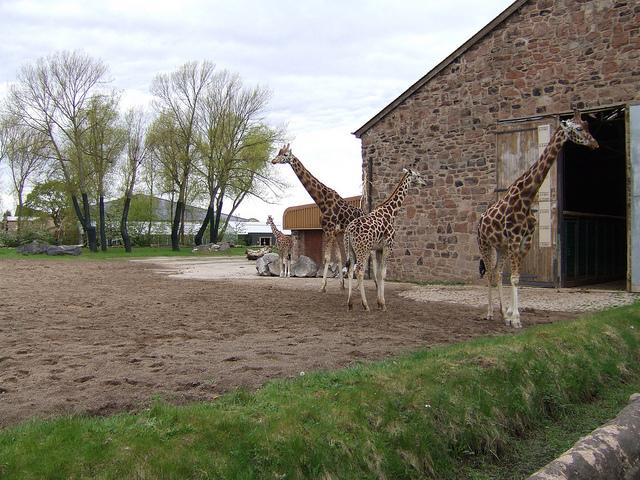What type of animal is shown? giraffe 